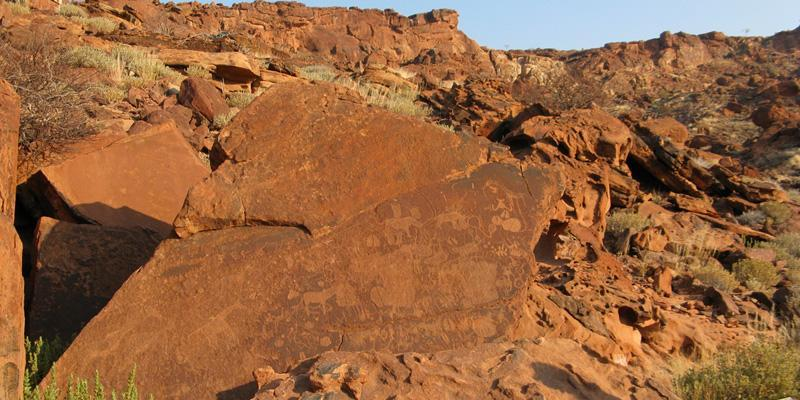Explore the historical significance of the engravings. The Twyfelfontein rock engravings hold tremendous historical significance as they are among the oldest rock art sites in Africa, dating back approximately 6,000 years. These petroglyphs were created by the San people, who were skilled hunter-gatherers and are regarded as one of the earliest human inhabitants of the region. The engravings served multiple purposes, from marking territories to recording significant events and illustrating the San people's deep connection to nature and their environment. As such, they provide invaluable insights into the early human societies' socio-cultural and spiritual life. Are there any notable animal engravings in the image? Yes, the image features a number of notable animal engravings. Among them are giraffes, lions, and antelopes, each intricately carved into the rock surface. These representations not only showcase the artistic skills of the San people but also reflect the diverse wildlife that inhabited the region thousands of years ago. The presence of such animals in the engravings indicates their importance in the San people's daily life, whether for sustenance, symbols of spiritual significance, or objects of reverence. Imagine a scenario where these engravings were used in a daily ritual. Describe it in detail. Picture a dusky evening in ancient Namibia. The San people gather around the engraved rock, the setting sun casting long shadows and illuminating the carvings in a warm golden hue. Elders of the community, adorned with traditional beads and attire, begin the evening ritual by recounting tales of hunt and survival, pointing to the animal figures etched on the rock. These stories are accompanied by rhythmic drumming and chanting, invoking the spirits of the depicted animals for blessings and guidance.

Children, wide-eyed with wonder, listen attentively, their faces lit by the flickering flames of a central fire. The ritual progresses with a dance, where participants mimic the movements of the animals depicted, believing that such actions would ensure successful hunts and harmony with nature. The engravings, thus, come to life in the blend of storytelling, music, and dance, fostering a sense of community and continuity with their ancestors. This practice not only strengthens social bonds but reaffirms their spiritual connection to the land and its inhabitants, highlighting the engravings' central role in their cultural and daily life. What's a more casual, yet intriguing, aspect of this site? A cool, casual aspect of Twyfelfontein is how these ancient engravings have survived for millennia despite the tough desert conditions. The fact that you can still see these detailed carvings, etched thousands of years ago by humans, tells us a lot about their resilience and the meticulous techniques they used. It's like peering directly into the past, holding up incredibly well against the elements! 